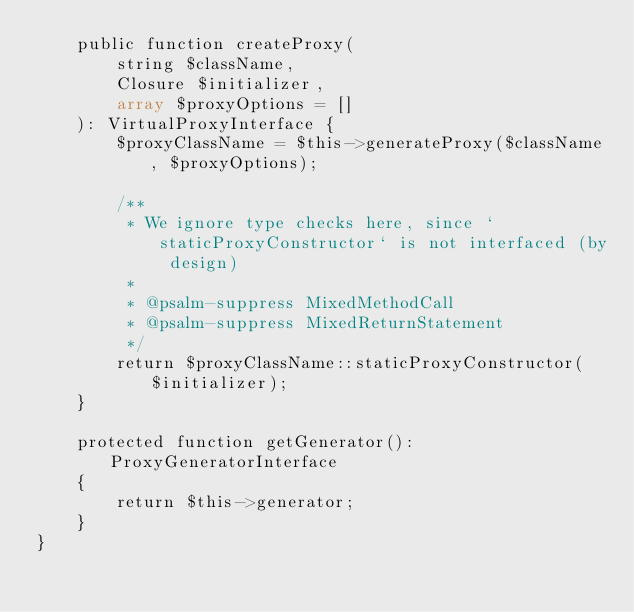Convert code to text. <code><loc_0><loc_0><loc_500><loc_500><_PHP_>    public function createProxy(
        string $className,
        Closure $initializer,
        array $proxyOptions = []
    ): VirtualProxyInterface {
        $proxyClassName = $this->generateProxy($className, $proxyOptions);

        /**
         * We ignore type checks here, since `staticProxyConstructor` is not interfaced (by design)
         *
         * @psalm-suppress MixedMethodCall
         * @psalm-suppress MixedReturnStatement
         */
        return $proxyClassName::staticProxyConstructor($initializer);
    }

    protected function getGenerator(): ProxyGeneratorInterface
    {
        return $this->generator;
    }
}
</code> 